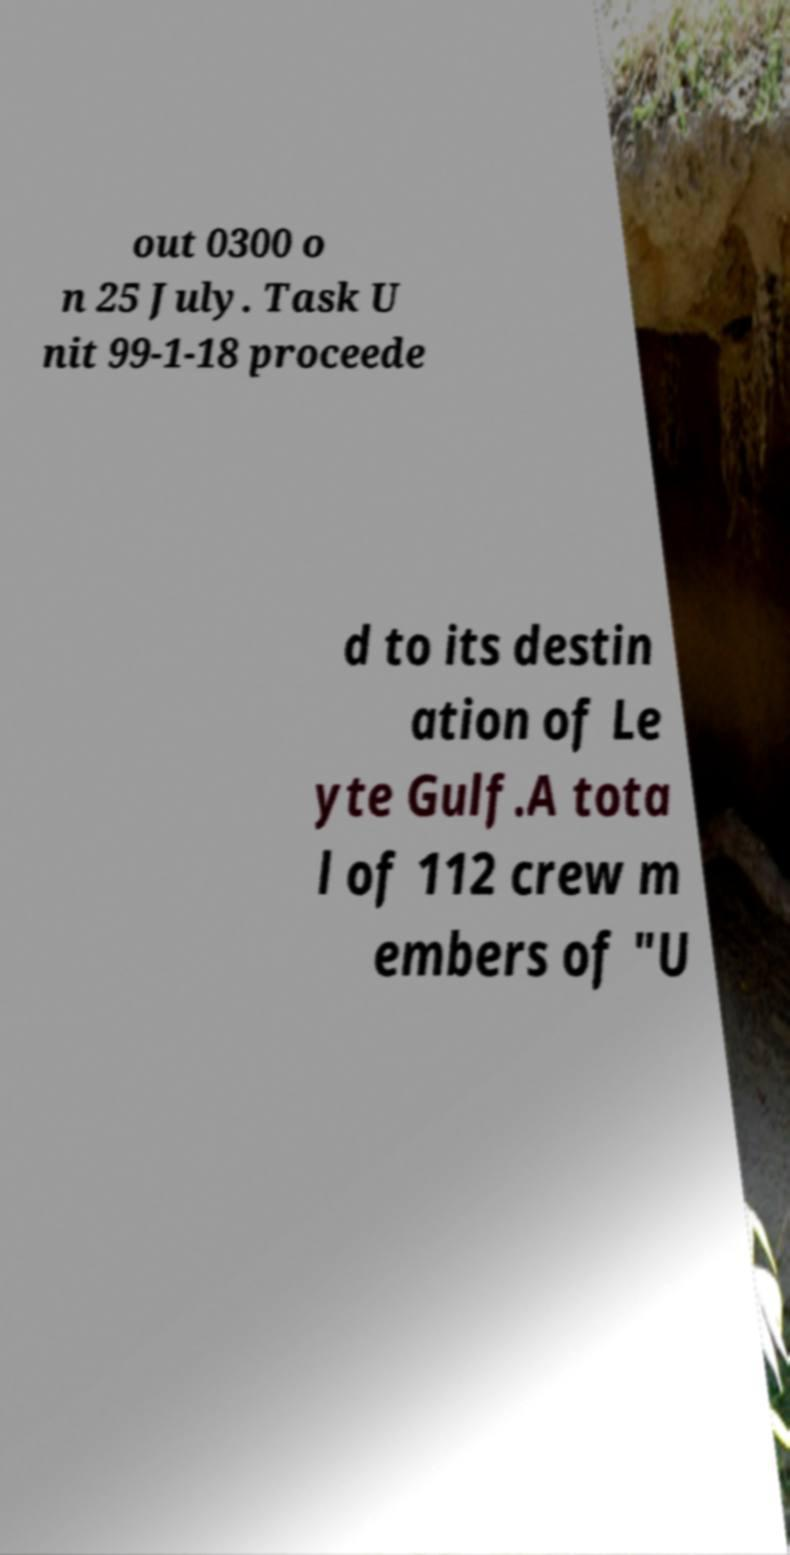Please identify and transcribe the text found in this image. out 0300 o n 25 July. Task U nit 99-1-18 proceede d to its destin ation of Le yte Gulf.A tota l of 112 crew m embers of "U 